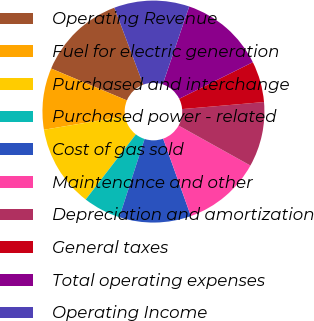Convert chart to OTSL. <chart><loc_0><loc_0><loc_500><loc_500><pie_chart><fcel>Operating Revenue<fcel>Fuel for electric generation<fcel>Purchased and interchange<fcel>Purchased power - related<fcel>Cost of gas sold<fcel>Maintenance and other<fcel>Depreciation and amortization<fcel>General taxes<fcel>Total operating expenses<fcel>Operating Income<nl><fcel>12.93%<fcel>8.96%<fcel>11.94%<fcel>5.47%<fcel>10.45%<fcel>11.44%<fcel>9.45%<fcel>5.97%<fcel>12.44%<fcel>10.95%<nl></chart> 